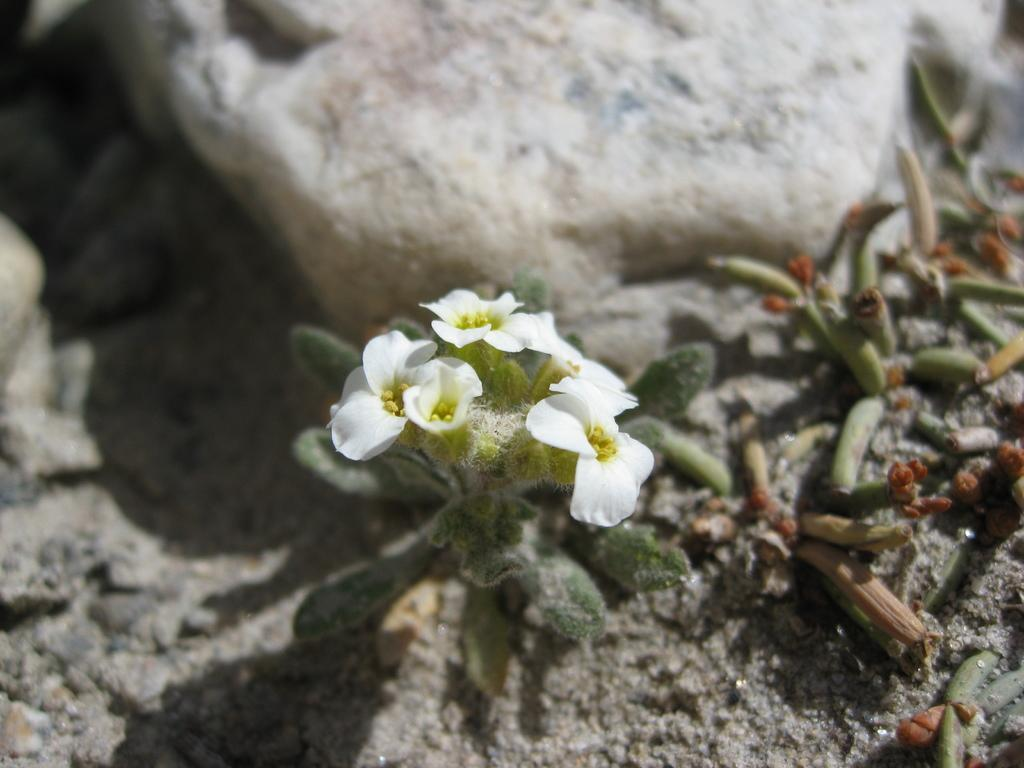What type of flower is visible in the image? There is a white flower in the image. What else can be seen in the image besides the flower? There are leaves in the image, which belong to a plant. What is the position of the rock in the image? The rock is on the top of the image. What can be found on the right side of the image? There are some buds on the right side of the image, and they are on the floor. What type of throat can be seen in the image? There is no throat present in the image; it features a white flower, leaves, a rock, and some buds. How many fingers are visible in the image? There are no fingers visible in the image. 